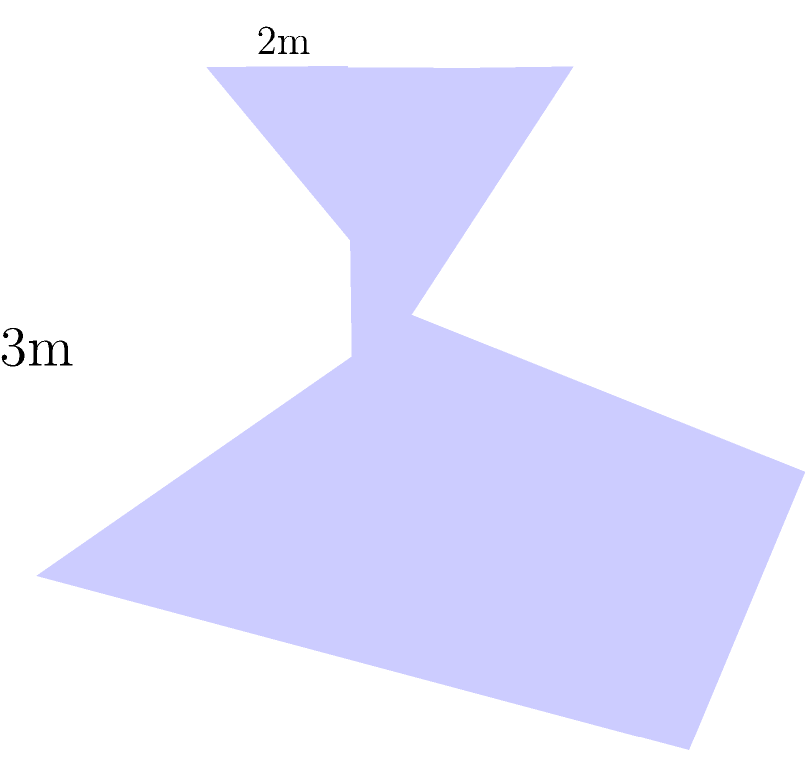As a proud supporter of the APC in Osun State, you've been asked to calculate the volume of a new water tank for a community project. The tank is shaped like a truncated pyramid with a square base of side length 4 meters, a square top of side length 2 meters, and a height of 3 meters. What is the volume of this water tank in cubic meters? To calculate the volume of a truncated pyramid, we'll use the formula:

$$V = \frac{1}{3}h(A_1 + A_2 + \sqrt{A_1A_2})$$

Where:
$V$ = Volume
$h$ = Height
$A_1$ = Area of the base
$A_2$ = Area of the top

Step 1: Calculate the area of the base ($A_1$)
$$A_1 = 4m \times 4m = 16m^2$$

Step 2: Calculate the area of the top ($A_2$)
$$A_2 = 2m \times 2m = 4m^2$$

Step 3: Calculate $\sqrt{A_1A_2}$
$$\sqrt{A_1A_2} = \sqrt{16m^2 \times 4m^2} = \sqrt{64m^4} = 8m^2$$

Step 4: Apply the formula
$$V = \frac{1}{3} \times 3m(16m^2 + 4m^2 + 8m^2)$$
$$V = 1m(28m^2)$$
$$V = 28m^3$$

Therefore, the volume of the water tank is 28 cubic meters.
Answer: 28 m³ 